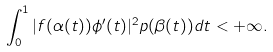<formula> <loc_0><loc_0><loc_500><loc_500>\int _ { 0 } ^ { 1 } | f ( \alpha ( t ) ) \phi { ^ { \prime } } ( t ) | ^ { 2 } p ( \beta ( t ) ) d t < + \infty .</formula> 